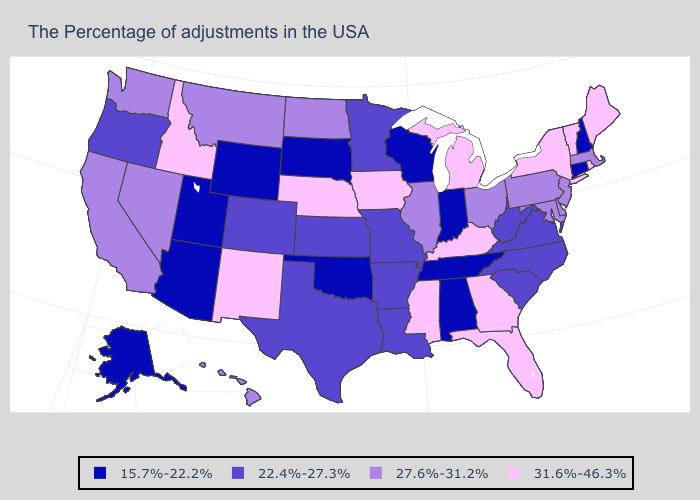Name the states that have a value in the range 15.7%-22.2%?
Short answer required. New Hampshire, Connecticut, Indiana, Alabama, Tennessee, Wisconsin, Oklahoma, South Dakota, Wyoming, Utah, Arizona, Alaska. Which states have the highest value in the USA?
Concise answer only. Maine, Rhode Island, Vermont, New York, Florida, Georgia, Michigan, Kentucky, Mississippi, Iowa, Nebraska, New Mexico, Idaho. What is the value of Hawaii?
Be succinct. 27.6%-31.2%. What is the value of Nebraska?
Be succinct. 31.6%-46.3%. What is the lowest value in states that border Colorado?
Quick response, please. 15.7%-22.2%. Does Vermont have the lowest value in the USA?
Short answer required. No. What is the value of New Hampshire?
Quick response, please. 15.7%-22.2%. How many symbols are there in the legend?
Be succinct. 4. What is the highest value in states that border Michigan?
Short answer required. 27.6%-31.2%. Name the states that have a value in the range 22.4%-27.3%?
Write a very short answer. Virginia, North Carolina, South Carolina, West Virginia, Louisiana, Missouri, Arkansas, Minnesota, Kansas, Texas, Colorado, Oregon. Among the states that border Alabama , which have the highest value?
Quick response, please. Florida, Georgia, Mississippi. Which states have the lowest value in the West?
Short answer required. Wyoming, Utah, Arizona, Alaska. What is the lowest value in the USA?
Keep it brief. 15.7%-22.2%. Does the map have missing data?
Give a very brief answer. No. Name the states that have a value in the range 27.6%-31.2%?
Keep it brief. Massachusetts, New Jersey, Delaware, Maryland, Pennsylvania, Ohio, Illinois, North Dakota, Montana, Nevada, California, Washington, Hawaii. 